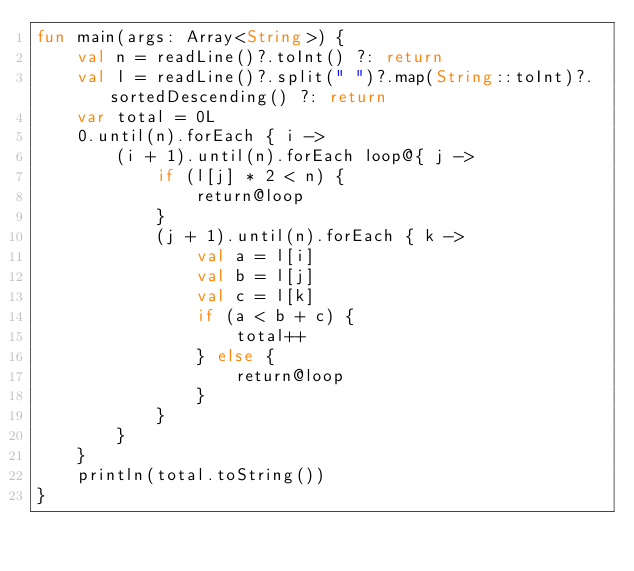<code> <loc_0><loc_0><loc_500><loc_500><_Kotlin_>fun main(args: Array<String>) {
    val n = readLine()?.toInt() ?: return
    val l = readLine()?.split(" ")?.map(String::toInt)?.sortedDescending() ?: return
    var total = 0L
    0.until(n).forEach { i ->
        (i + 1).until(n).forEach loop@{ j ->
            if (l[j] * 2 < n) {
                return@loop
            }
            (j + 1).until(n).forEach { k ->
                val a = l[i]
                val b = l[j]
                val c = l[k]
                if (a < b + c) {
                    total++
                } else {
                    return@loop
                }
            }
        }
    }
    println(total.toString())
}</code> 